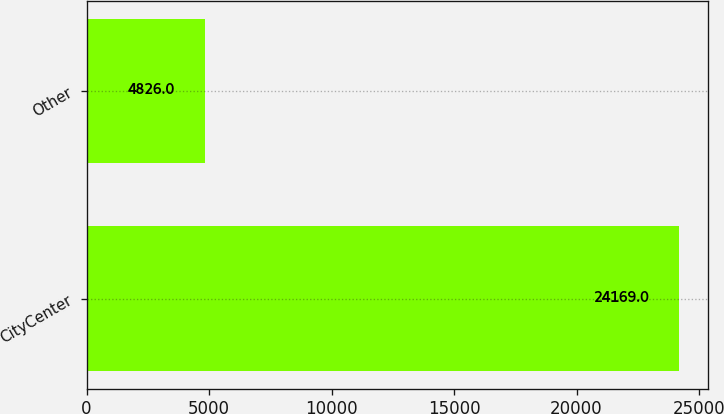Convert chart. <chart><loc_0><loc_0><loc_500><loc_500><bar_chart><fcel>CityCenter<fcel>Other<nl><fcel>24169<fcel>4826<nl></chart> 